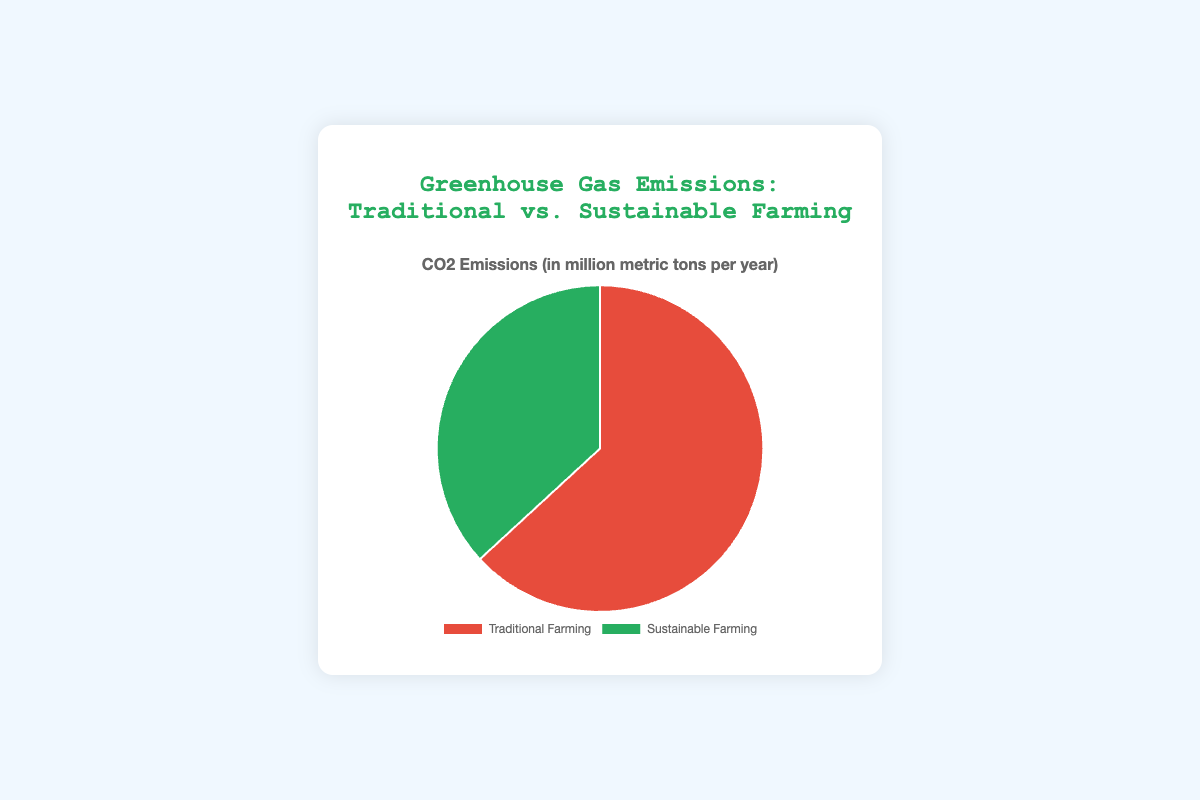What is the CO2 emission for Traditional Farming? The chart indicates that the CO2 emission for Traditional Farming is represented in the pie chart with the corresponding section showing the value. It states that Traditional Farming has 60 million metric tons per year.
Answer: 60 million metric tons per year What is the CO2 emission for Sustainable Farming? The chart indicates that the CO2 emission for Sustainable Farming is represented in the pie chart with the corresponding section showing the value. It states that Sustainable Farming has 35 million metric tons per year.
Answer: 35 million metric tons per year Which farming practice has higher CO2 emissions? By comparing the two values in the pie chart, Traditional Farming shows a higher emission (60 million metric tons per year) compared to Sustainable Farming (35 million metric tons per year).
Answer: Traditional Farming By how much do Traditional Farming CO2 emissions exceed Sustainable Farming emissions? Traditional Farming emissions (60 million metric tons per year) minus Sustainable Farming emissions (35 million metric tons per year) gives the difference. The calculation is 60 - 35.
Answer: 25 million metric tons per year What percentage of the total emissions does Sustainable Farming contribute? To find the percentage, first calculate the total emissions which is 60 + 35 = 95 million metric tons per year. Then divide Sustainable Farming emissions by the total emissions and multiply by 100. (35/95) * 100 ≈ 36.84%
Answer: Approximately 36.84% What is the total CO2 emissions for both farming practices combined? Add the CO2 emissions from Traditional Farming (60 million metric tons per year) and Sustainable Farming (35 million metric tons per year). The calculation is 60 + 35.
Answer: 95 million metric tons per year What is the ratio of Traditional Farming CO2 emissions to Sustainable Farming CO2 emissions? Divide the emissions from Traditional Farming by those from Sustainable Farming. The calculation is 60 / 35 which simplifies.
Answer: Approximately 1.71 What fraction of the emissions is from Sustainable Farming? Divide the emissions from Sustainable Farming by the total emissions. The calculation is 35 / 95.
Answer: Approximately 7/19 Which section of the pie chart is smaller, and what does it represent? Visually, the pie chart shows the smaller section representing Sustainable Farming. It is colored differently (green) from the Traditional Farming section (red).
Answer: Sustainable Farming If the emissions from Traditional Farming were reduced by 10%, what would the new emission value be? Calculate 10% of the Traditional Farming emissions (60 million metric tons per year), which is 60 * 0.10 = 6. Subtract this from the original emissions. The calculation is 60 - 6.
Answer: 54 million metric tons per year 